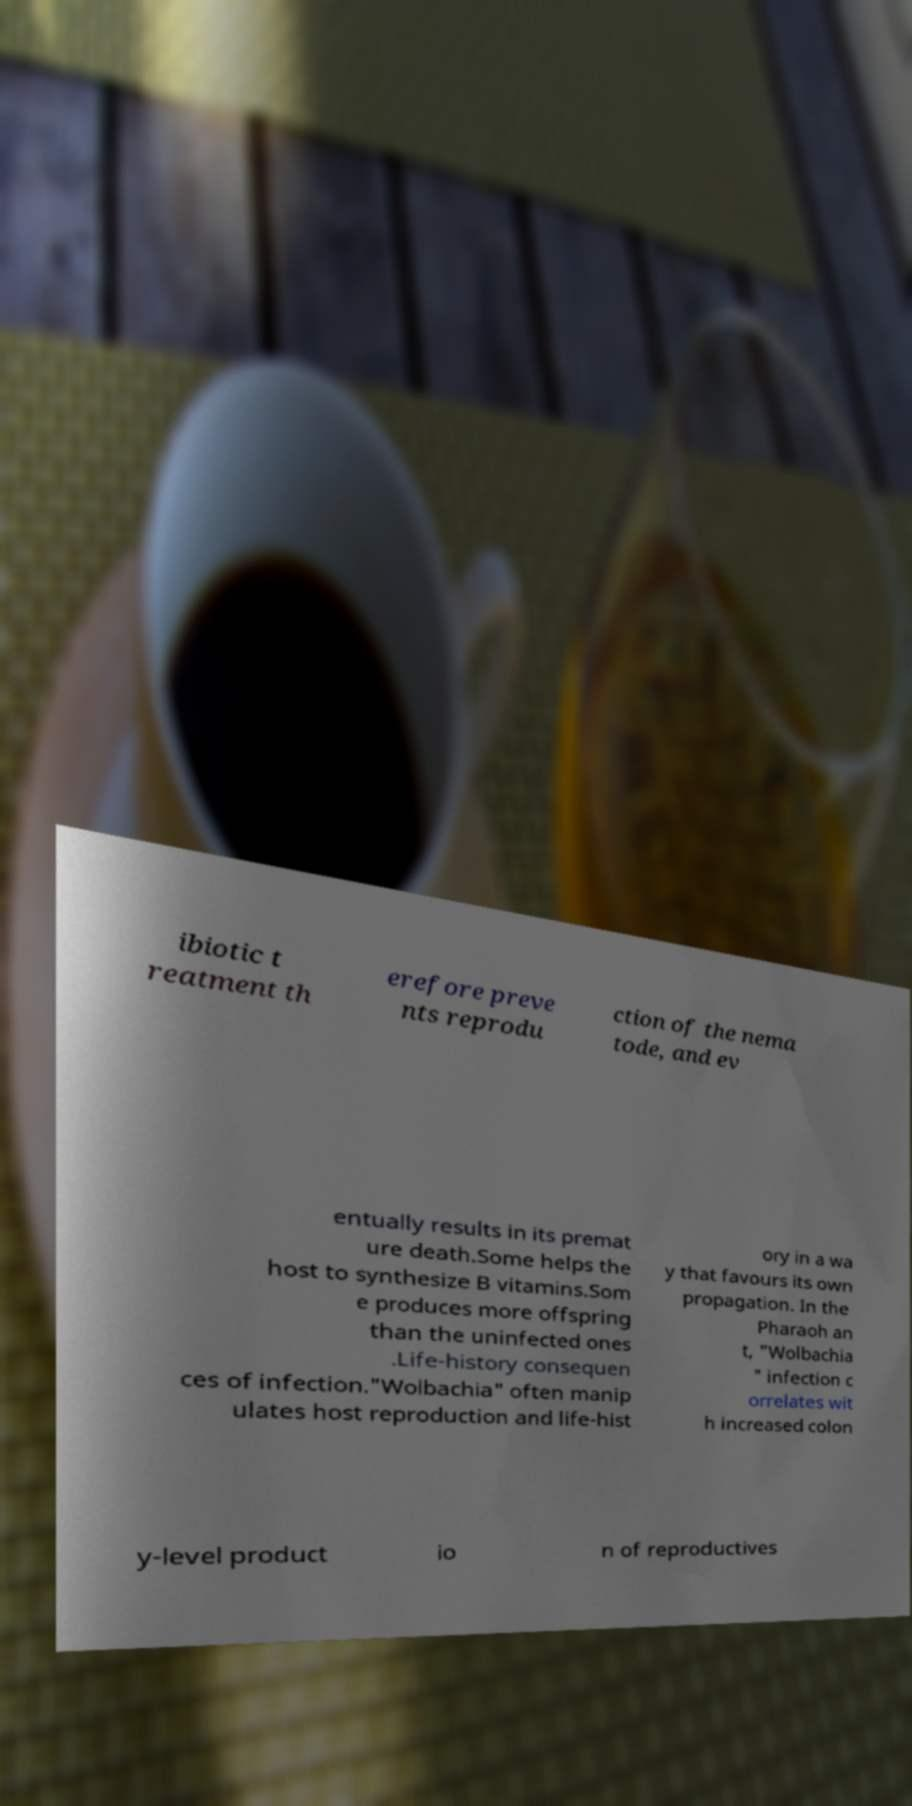There's text embedded in this image that I need extracted. Can you transcribe it verbatim? ibiotic t reatment th erefore preve nts reprodu ction of the nema tode, and ev entually results in its premat ure death.Some helps the host to synthesize B vitamins.Som e produces more offspring than the uninfected ones .Life-history consequen ces of infection."Wolbachia" often manip ulates host reproduction and life-hist ory in a wa y that favours its own propagation. In the Pharaoh an t, "Wolbachia " infection c orrelates wit h increased colon y-level product io n of reproductives 